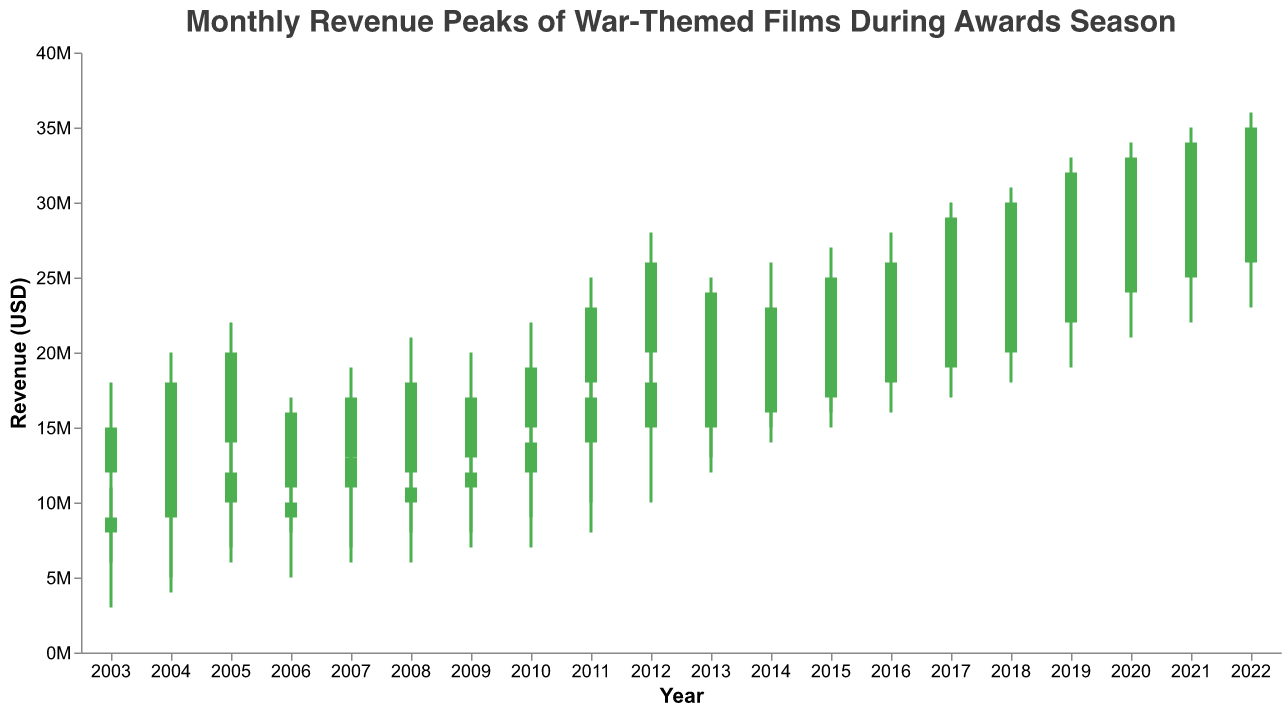What is the title of the plot? The title is prominently displayed at the top of the plot. It states, "Monthly Revenue Peaks of War-Themed Films During Awards Season."
Answer: Monthly Revenue Peaks of War-Themed Films During Awards Season Which month typically has higher revenues, January or February? By comparing the revenues for January and February across the years on the plot, January generally shows higher revenues than February.
Answer: January For the year 2022, what is the highest revenue recorded? For the year 2022, the peak revenue can be found by looking at the highest point of the candlestick for January or February. It shows up as $36,000,000 in January.
Answer: $36,000,000 Which year shows the greatest difference between the highest and lowest revenues in a single month? To find the year with the greatest revenue difference, check each year and calculate (High - Low) for the month with the greatest deviation. The year 2021 in January shows the highest variation, with a revenue range from $25,000,000 to $35,000,000, a difference of $10,000,000.
Answer: 2021 What is the color used to represent months where the close is higher than the open? The plot uses green color to represent months where the closing revenue exceeds the opening revenue, as indicated by the color legend.
Answer: Green How many years does the plot cover? By counting the distinct years on the x-axis, the plot covers data from 2003 to 2022, which is 20 years.
Answer: 20 years In which month and year did the revenue close at $29,000,000? Scan through the candlestick plot to find the closing revenue that matches $29,000,000. This occurs in February 2017.
Answer: February 2017 What is the overall trend in revenue peaks from 2003 to 2022? Observing the general movement of the highest points of the candlesticks over the years, the trend shows a consistent increase in revenues from 2003 to 2022.
Answer: Increasing trend Which year had the smallest revenue difference between January and February? Inspect the months January and February of each year and calculate the difference (January Close - February Close). The smallest difference is in 2004, where January closed at $18,000,000 and February at $11,000,000, a difference of $7,000,000.
Answer: 2004 What was the lowest revenue recorded in the plot and in which month and year was it? To find the lowest recorded revenue, look at the lowest points of the candlesticks. The lowest revenue was $3,000,000 recorded in February 2003.
Answer: $3,000,000 in February 2003 